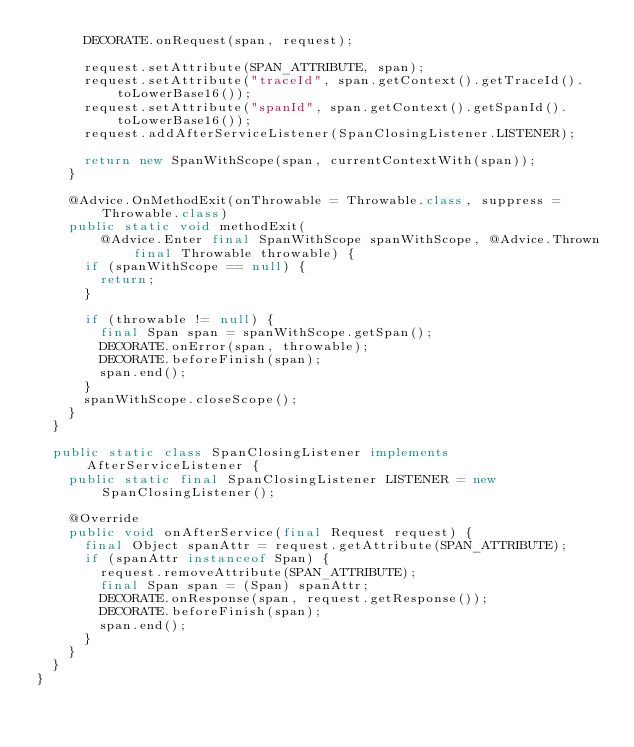Convert code to text. <code><loc_0><loc_0><loc_500><loc_500><_Java_>      DECORATE.onRequest(span, request);

      request.setAttribute(SPAN_ATTRIBUTE, span);
      request.setAttribute("traceId", span.getContext().getTraceId().toLowerBase16());
      request.setAttribute("spanId", span.getContext().getSpanId().toLowerBase16());
      request.addAfterServiceListener(SpanClosingListener.LISTENER);

      return new SpanWithScope(span, currentContextWith(span));
    }

    @Advice.OnMethodExit(onThrowable = Throwable.class, suppress = Throwable.class)
    public static void methodExit(
        @Advice.Enter final SpanWithScope spanWithScope, @Advice.Thrown final Throwable throwable) {
      if (spanWithScope == null) {
        return;
      }

      if (throwable != null) {
        final Span span = spanWithScope.getSpan();
        DECORATE.onError(span, throwable);
        DECORATE.beforeFinish(span);
        span.end();
      }
      spanWithScope.closeScope();
    }
  }

  public static class SpanClosingListener implements AfterServiceListener {
    public static final SpanClosingListener LISTENER = new SpanClosingListener();

    @Override
    public void onAfterService(final Request request) {
      final Object spanAttr = request.getAttribute(SPAN_ATTRIBUTE);
      if (spanAttr instanceof Span) {
        request.removeAttribute(SPAN_ATTRIBUTE);
        final Span span = (Span) spanAttr;
        DECORATE.onResponse(span, request.getResponse());
        DECORATE.beforeFinish(span);
        span.end();
      }
    }
  }
}
</code> 